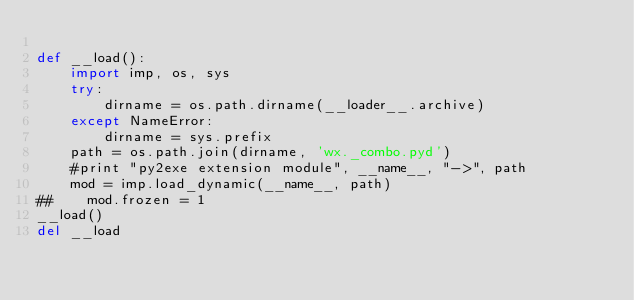Convert code to text. <code><loc_0><loc_0><loc_500><loc_500><_Python_>
def __load():
    import imp, os, sys
    try:
        dirname = os.path.dirname(__loader__.archive)
    except NameError:
        dirname = sys.prefix
    path = os.path.join(dirname, 'wx._combo.pyd')
    #print "py2exe extension module", __name__, "->", path
    mod = imp.load_dynamic(__name__, path)
##    mod.frozen = 1
__load()
del __load
</code> 